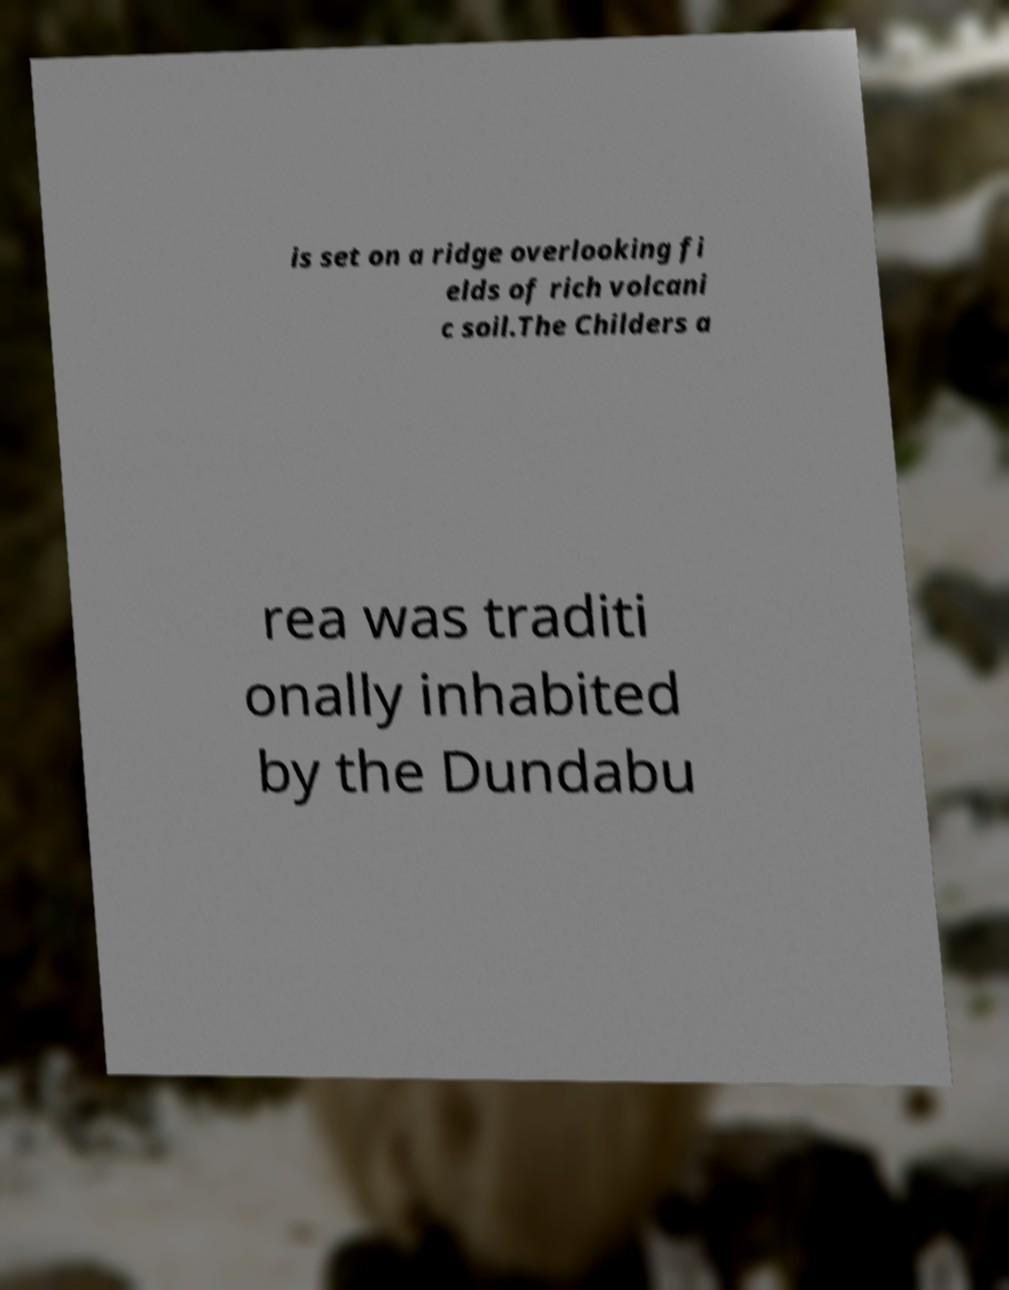Please read and relay the text visible in this image. What does it say? is set on a ridge overlooking fi elds of rich volcani c soil.The Childers a rea was traditi onally inhabited by the Dundabu 